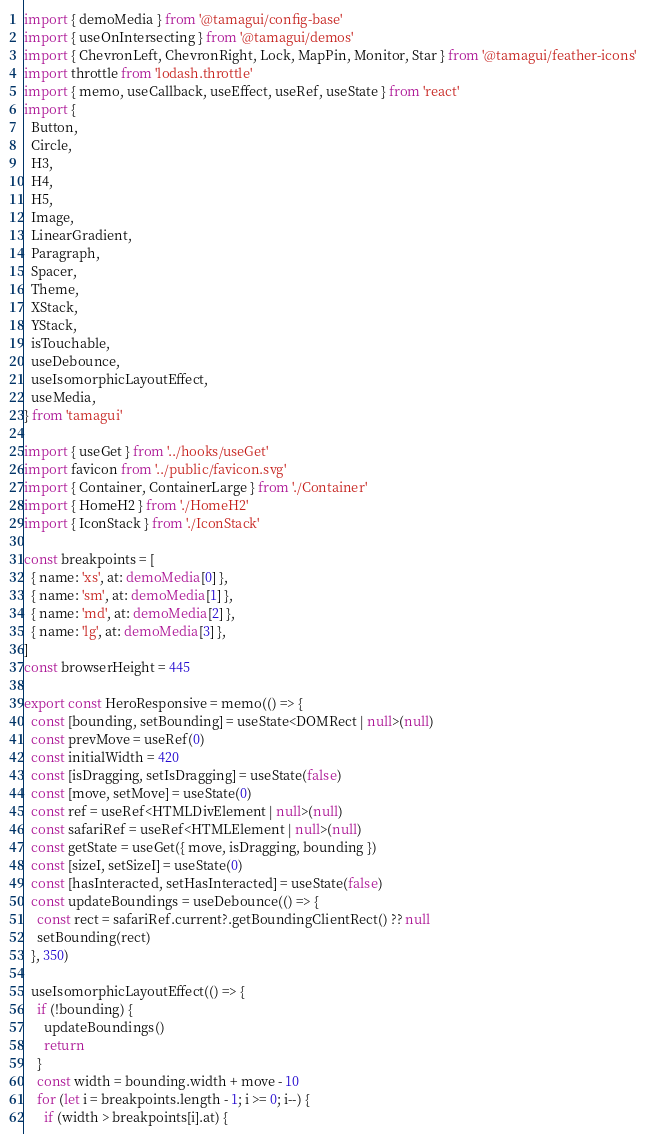<code> <loc_0><loc_0><loc_500><loc_500><_TypeScript_>import { demoMedia } from '@tamagui/config-base'
import { useOnIntersecting } from '@tamagui/demos'
import { ChevronLeft, ChevronRight, Lock, MapPin, Monitor, Star } from '@tamagui/feather-icons'
import throttle from 'lodash.throttle'
import { memo, useCallback, useEffect, useRef, useState } from 'react'
import {
  Button,
  Circle,
  H3,
  H4,
  H5,
  Image,
  LinearGradient,
  Paragraph,
  Spacer,
  Theme,
  XStack,
  YStack,
  isTouchable,
  useDebounce,
  useIsomorphicLayoutEffect,
  useMedia,
} from 'tamagui'

import { useGet } from '../hooks/useGet'
import favicon from '../public/favicon.svg'
import { Container, ContainerLarge } from './Container'
import { HomeH2 } from './HomeH2'
import { IconStack } from './IconStack'

const breakpoints = [
  { name: 'xs', at: demoMedia[0] },
  { name: 'sm', at: demoMedia[1] },
  { name: 'md', at: demoMedia[2] },
  { name: 'lg', at: demoMedia[3] },
]
const browserHeight = 445

export const HeroResponsive = memo(() => {
  const [bounding, setBounding] = useState<DOMRect | null>(null)
  const prevMove = useRef(0)
  const initialWidth = 420
  const [isDragging, setIsDragging] = useState(false)
  const [move, setMove] = useState(0)
  const ref = useRef<HTMLDivElement | null>(null)
  const safariRef = useRef<HTMLElement | null>(null)
  const getState = useGet({ move, isDragging, bounding })
  const [sizeI, setSizeI] = useState(0)
  const [hasInteracted, setHasInteracted] = useState(false)
  const updateBoundings = useDebounce(() => {
    const rect = safariRef.current?.getBoundingClientRect() ?? null
    setBounding(rect)
  }, 350)

  useIsomorphicLayoutEffect(() => {
    if (!bounding) {
      updateBoundings()
      return
    }
    const width = bounding.width + move - 10
    for (let i = breakpoints.length - 1; i >= 0; i--) {
      if (width > breakpoints[i].at) {</code> 